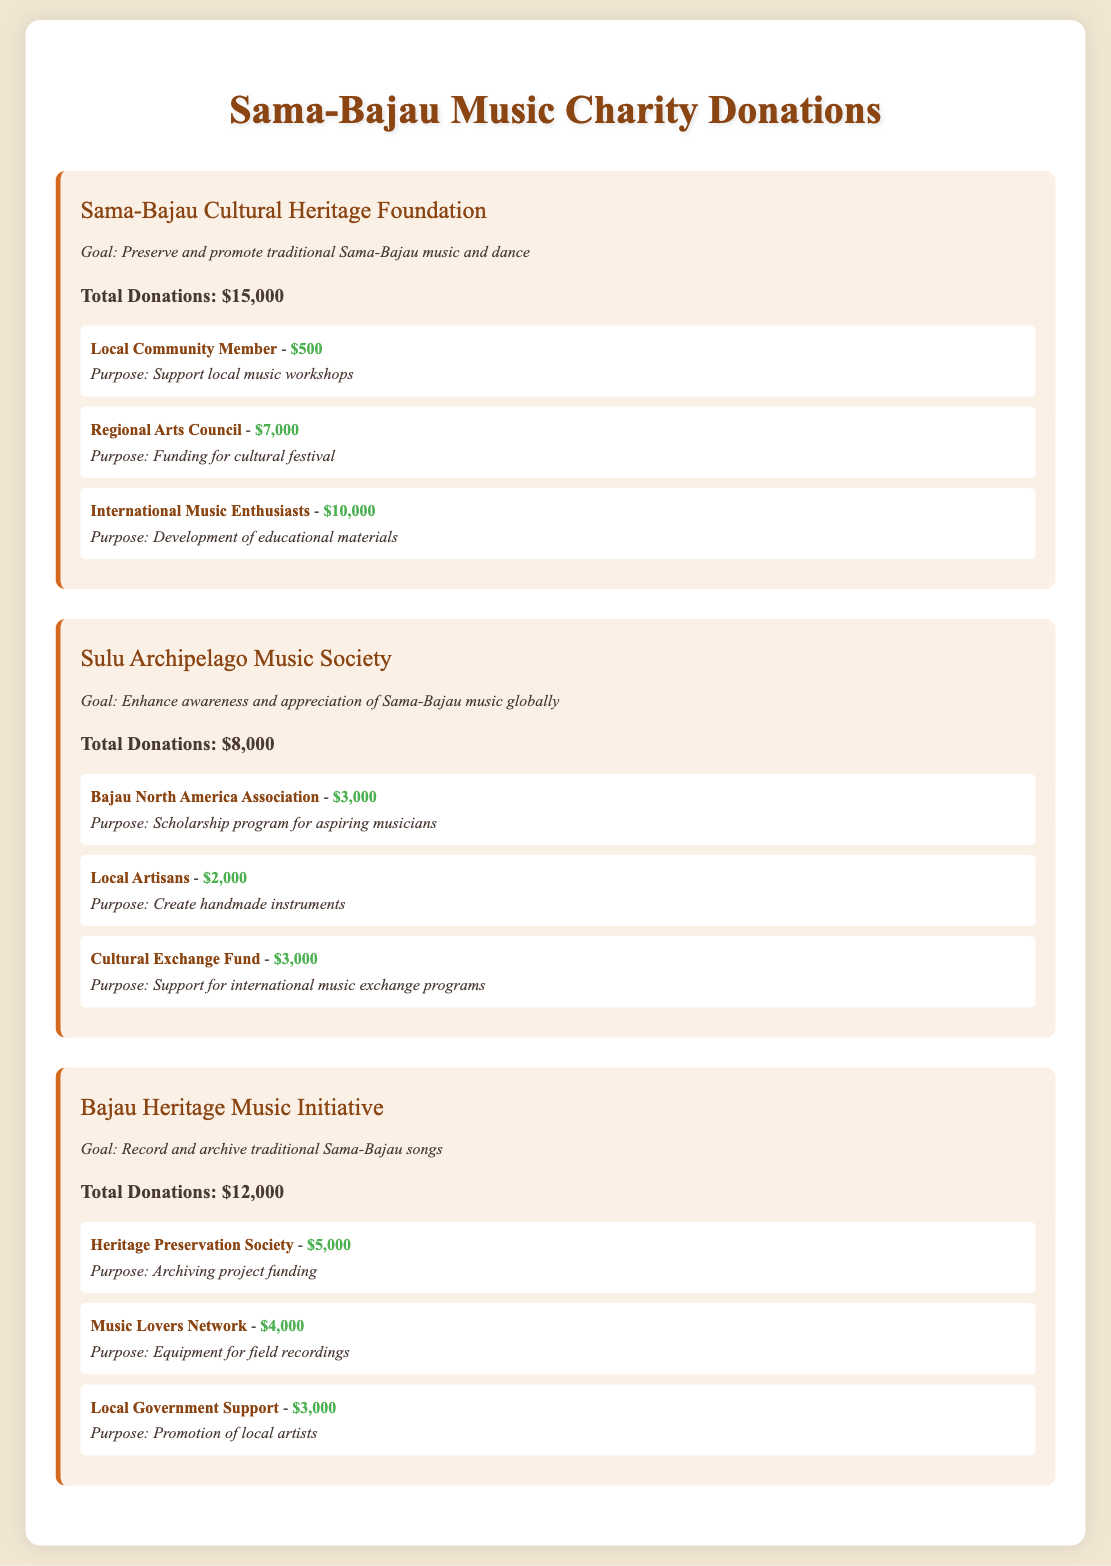What is the goal of the Sama-Bajau Cultural Heritage Foundation? The goal is to preserve and promote traditional Sama-Bajau music and dance.
Answer: Preserve and promote traditional Sama-Bajau music and dance How much did the International Music Enthusiasts contribute? The contribution amount from International Music Enthusiasts is clearly stated in the document.
Answer: $10,000 What is the total amount of donations for the Sulu Archipelago Music Society? The total donations amount for this organization is listed directly in the document.
Answer: $8,000 Which organization aims to record and archive traditional Sama-Bajau songs? The document specifies that the Bajau Heritage Music Initiative has this goal.
Answer: Bajau Heritage Music Initiative Who contributed the most to the Sama-Bajau Cultural Heritage Foundation? The document lists contribution amounts, making it clear who the largest contributor was.
Answer: Regional Arts Council What purpose does the Bajau North America Association's donation serve? The document explains the intended purpose of each donation, including that of the Bajau North America Association.
Answer: Scholarship program for aspiring musicians How much did the Local Government Support contribute to the Bajau Heritage Music Initiative? The contribution amount is detailed in the section pertaining to the Bajau Heritage Music Initiative.
Answer: $3,000 What is the total donations for the Bajau Heritage Music Initiative? The total for this organization is clearly mentioned in the document.
Answer: $12,000 How many organizations are detailed in the document? The document mentions a specific number of organizations involved in the donations.
Answer: Three 